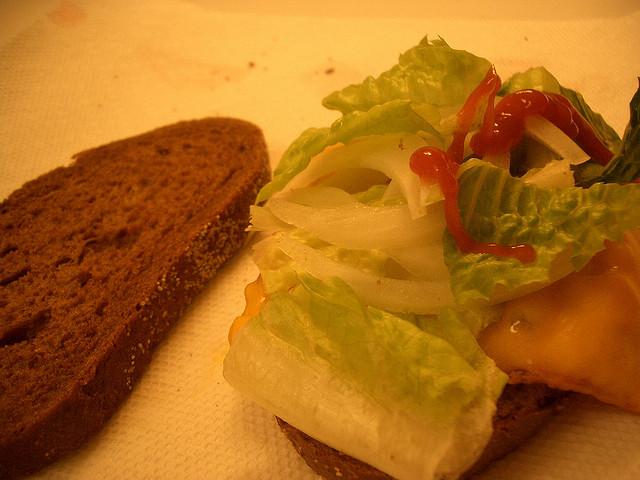Could that be rye?
Give a very brief answer. Yes. What is the sandwich resting on?
Give a very brief answer. Paper towel. Does this sandwich look tasty?
Short answer required. Yes. 